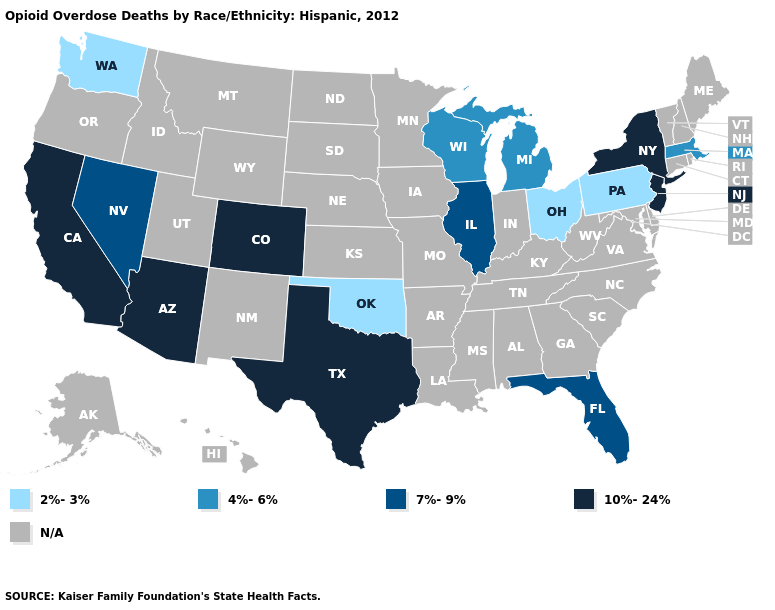Does Florida have the highest value in the South?
Quick response, please. No. Which states have the lowest value in the MidWest?
Short answer required. Ohio. Name the states that have a value in the range 10%-24%?
Keep it brief. Arizona, California, Colorado, New Jersey, New York, Texas. Among the states that border Iowa , does Wisconsin have the highest value?
Be succinct. No. What is the value of Alabama?
Quick response, please. N/A. What is the value of Idaho?
Answer briefly. N/A. Does Florida have the highest value in the South?
Answer briefly. No. Name the states that have a value in the range 10%-24%?
Quick response, please. Arizona, California, Colorado, New Jersey, New York, Texas. Name the states that have a value in the range 2%-3%?
Short answer required. Ohio, Oklahoma, Pennsylvania, Washington. Among the states that border Wisconsin , which have the highest value?
Give a very brief answer. Illinois. What is the value of Alabama?
Quick response, please. N/A. Does Texas have the highest value in the South?
Give a very brief answer. Yes. Which states have the highest value in the USA?
Be succinct. Arizona, California, Colorado, New Jersey, New York, Texas. What is the lowest value in the USA?
Give a very brief answer. 2%-3%. What is the value of Illinois?
Short answer required. 7%-9%. 